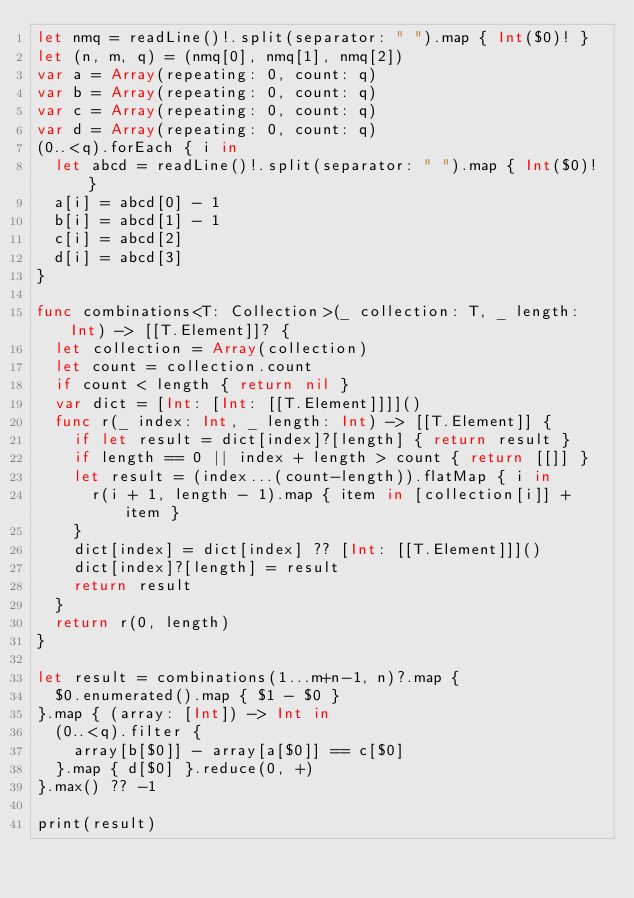Convert code to text. <code><loc_0><loc_0><loc_500><loc_500><_Swift_>let nmq = readLine()!.split(separator: " ").map { Int($0)! }
let (n, m, q) = (nmq[0], nmq[1], nmq[2])
var a = Array(repeating: 0, count: q)
var b = Array(repeating: 0, count: q)
var c = Array(repeating: 0, count: q)
var d = Array(repeating: 0, count: q)
(0..<q).forEach { i in
  let abcd = readLine()!.split(separator: " ").map { Int($0)! }
  a[i] = abcd[0] - 1
  b[i] = abcd[1] - 1
  c[i] = abcd[2]
  d[i] = abcd[3]
}

func combinations<T: Collection>(_ collection: T, _ length: Int) -> [[T.Element]]? {
  let collection = Array(collection)
  let count = collection.count
  if count < length { return nil }
  var dict = [Int: [Int: [[T.Element]]]]()
  func r(_ index: Int, _ length: Int) -> [[T.Element]] {
    if let result = dict[index]?[length] { return result }
    if length == 0 || index + length > count { return [[]] }
    let result = (index...(count-length)).flatMap { i in
      r(i + 1, length - 1).map { item in [collection[i]] + item }
    }
    dict[index] = dict[index] ?? [Int: [[T.Element]]]()
    dict[index]?[length] = result
    return result
  }
  return r(0, length)
}

let result = combinations(1...m+n-1, n)?.map {
  $0.enumerated().map { $1 - $0 }
}.map { (array: [Int]) -> Int in
  (0..<q).filter {
    array[b[$0]] - array[a[$0]] == c[$0]
  }.map { d[$0] }.reduce(0, +)
}.max() ?? -1

print(result)
</code> 